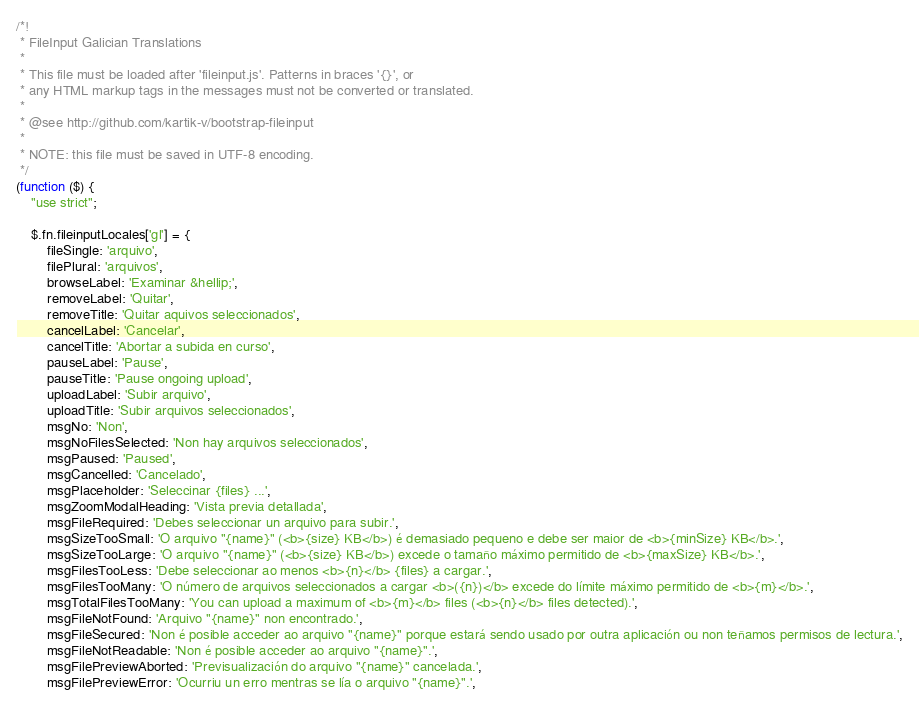<code> <loc_0><loc_0><loc_500><loc_500><_JavaScript_>/*!
 * FileInput Galician Translations
 *
 * This file must be loaded after 'fileinput.js'. Patterns in braces '{}', or
 * any HTML markup tags in the messages must not be converted or translated.
 *
 * @see http://github.com/kartik-v/bootstrap-fileinput
 *
 * NOTE: this file must be saved in UTF-8 encoding.
 */
(function ($) {
    "use strict";

    $.fn.fileinputLocales['gl'] = {
        fileSingle: 'arquivo',
        filePlural: 'arquivos',
        browseLabel: 'Examinar &hellip;',
        removeLabel: 'Quitar',
        removeTitle: 'Quitar aquivos seleccionados',
        cancelLabel: 'Cancelar',
        cancelTitle: 'Abortar a subida en curso',
        pauseLabel: 'Pause',
        pauseTitle: 'Pause ongoing upload',
        uploadLabel: 'Subir arquivo',
        uploadTitle: 'Subir arquivos seleccionados',
        msgNo: 'Non',
        msgNoFilesSelected: 'Non hay arquivos seleccionados',
        msgPaused: 'Paused',
        msgCancelled: 'Cancelado',
        msgPlaceholder: 'Seleccinar {files} ...',
        msgZoomModalHeading: 'Vista previa detallada',
        msgFileRequired: 'Debes seleccionar un arquivo para subir.',
        msgSizeTooSmall: 'O arquivo "{name}" (<b>{size} KB</b>) é demasiado pequeno e debe ser maior de <b>{minSize} KB</b>.',
        msgSizeTooLarge: 'O arquivo "{name}" (<b>{size} KB</b>) excede o tamaño máximo permitido de <b>{maxSize} KB</b>.',
        msgFilesTooLess: 'Debe seleccionar ao menos <b>{n}</b> {files} a cargar.',
        msgFilesTooMany: 'O número de arquivos seleccionados a cargar <b>({n})</b> excede do límite máximo permitido de <b>{m}</b>.',
        msgTotalFilesTooMany: 'You can upload a maximum of <b>{m}</b> files (<b>{n}</b> files detected).',
        msgFileNotFound: 'Arquivo "{name}" non encontrado.',
        msgFileSecured: 'Non é posible acceder ao arquivo "{name}" porque estará sendo usado por outra aplicación ou non teñamos permisos de lectura.',
        msgFileNotReadable: 'Non é posible acceder ao arquivo "{name}".',
        msgFilePreviewAborted: 'Previsualización do arquivo "{name}" cancelada.',
        msgFilePreviewError: 'Ocurriu un erro mentras se lía o arquivo "{name}".',</code> 